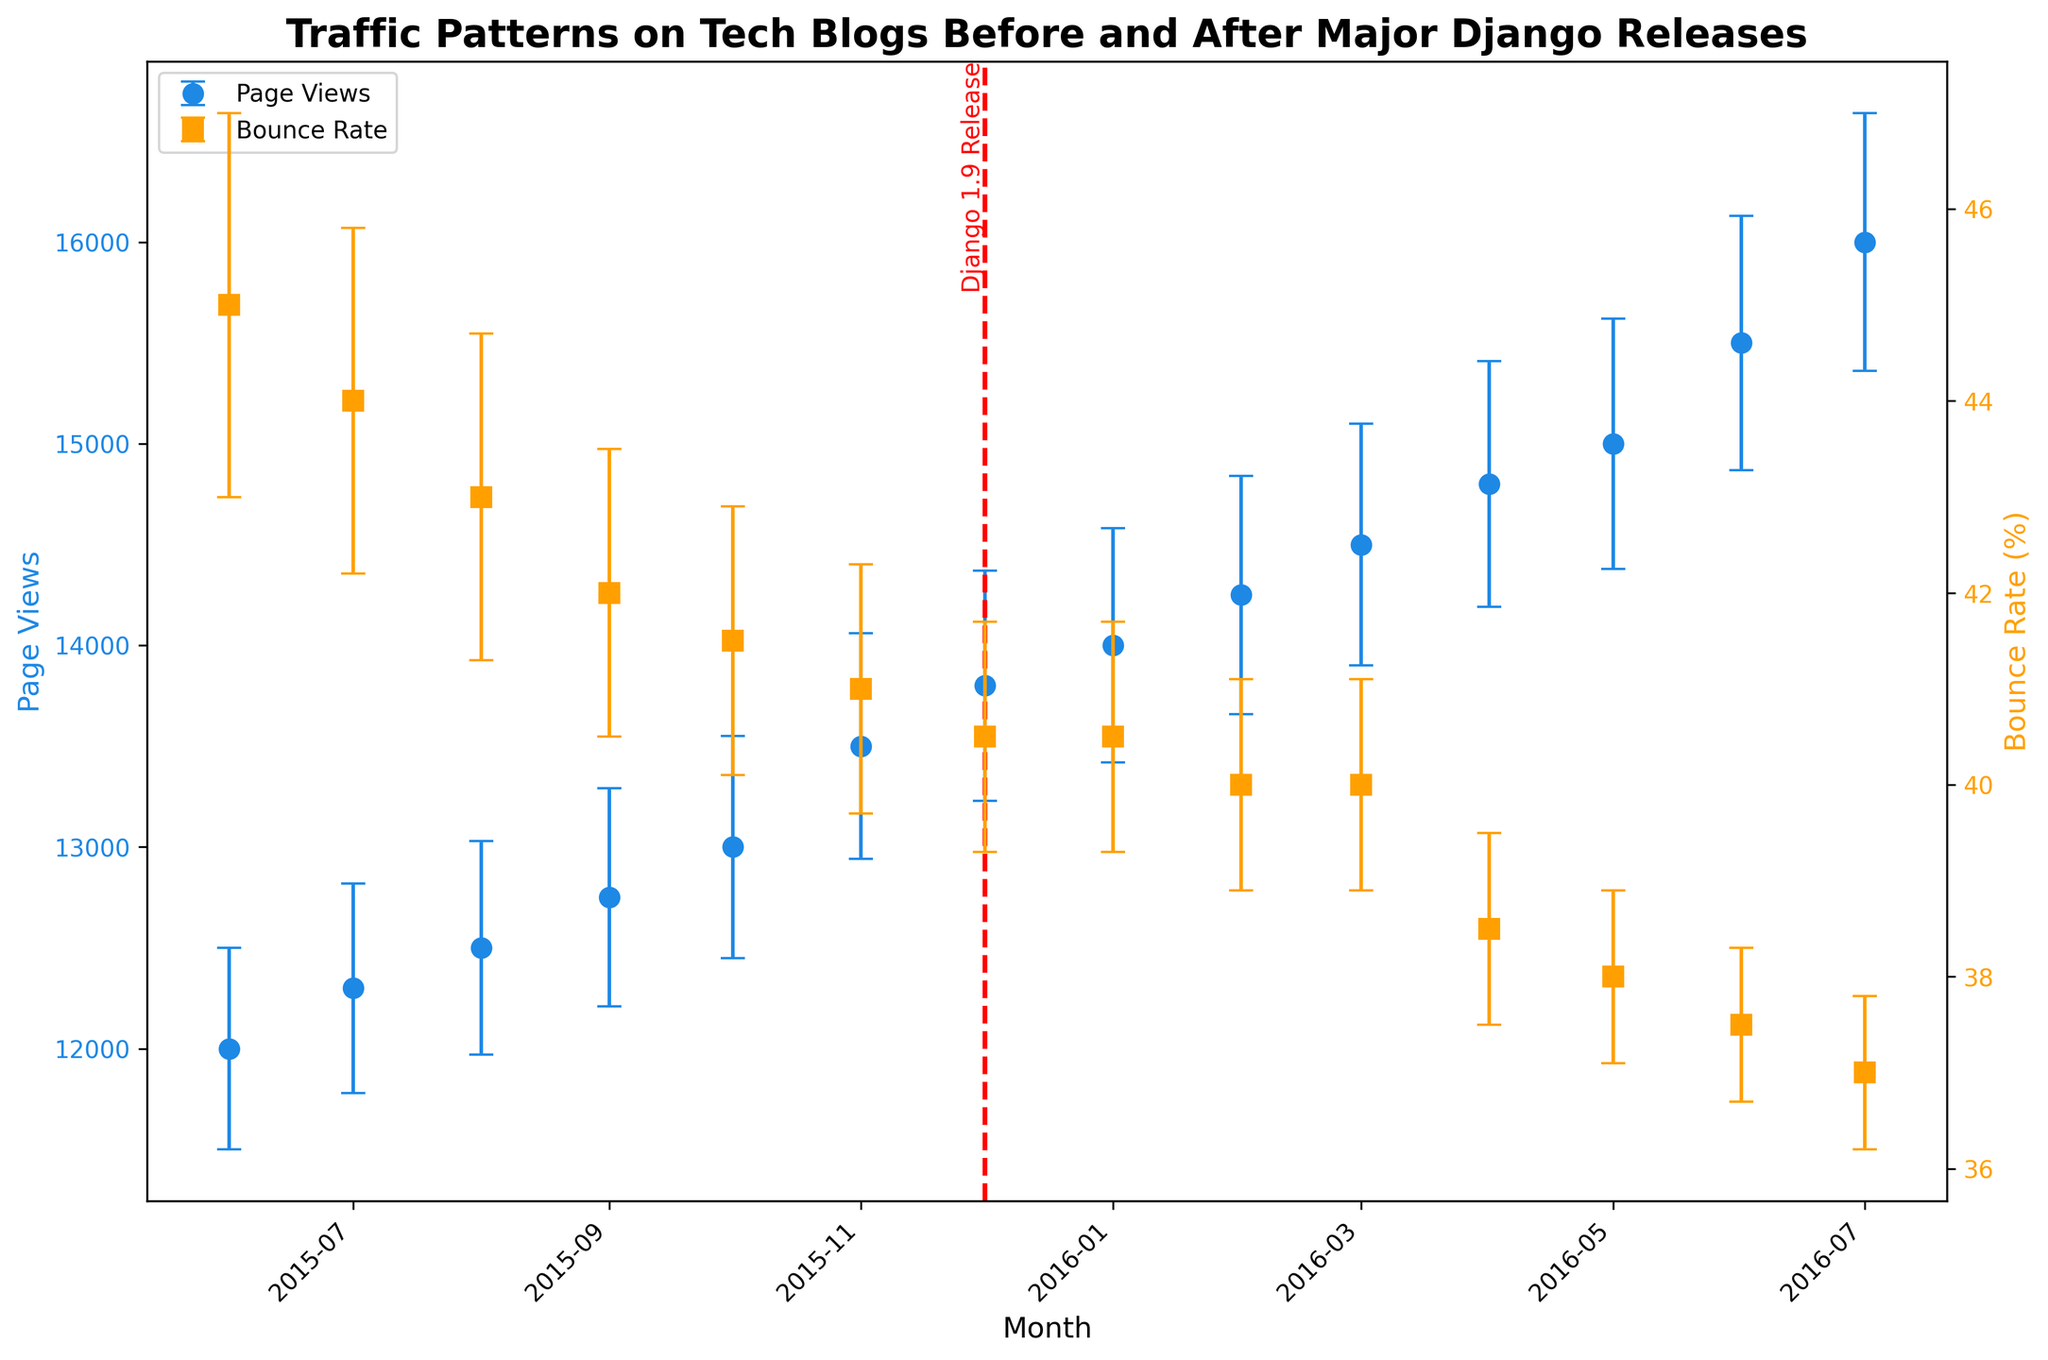What is the title of the plot? The title is displayed at the top of the plot. It reads: "Traffic Patterns on Tech Blogs Before and After Major Django Releases".
Answer: Traffic Patterns on Tech Blogs Before and After Major Django Releases What do the colors blue and orange represent in the plot? The colors are associated with the legends given on the plot. Blue (represented by circle markers) is for Page Views, and orange (represented by square markers) is for Bounce Rate.
Answer: Page Views (blue) and Bounce Rate (orange) How do the average page views change from June 2015 to July 2015? The y-axis value for page views increases from June to July. June shows an average of 12,000 page views, while July shows 12,300 page views, indicating an increase.
Answer: Increase from 12,000 to 12,300 What is the trend in the bounce rate from June 2015 to July 2016? The bounce rate generally decreases over time. In June 2015, it started at 45% and decreased to 37% by July 2016.
Answer: Decreasing trend How is the average bounce rate in March 2016 compared to that in April 2016? The plot shows that the average bounce rate in March 2016 is 40%, while in April 2016, it is 38.5%. This indicates a decrease in the bounce rate.
Answer: March 40%, April 38.5% What is the significance of the red vertical line on the plot? The red vertical line marks the release date of Django 1.9, which is December 1, 2015. It signifies that data before and after this date are separated for analysis.
Answer: Django 1.9 release date What is the error margin for page views in August 2015? The error margin for page views in August 2015 can be found using the Page_Views_STD value, which is ±530.
Answer: ±530 How does the variation in bounce rate (standard deviation) change from October 2015 to November 2015? The variation in bounce rate slightly decreases, with October having a standard deviation of 1.4 and November having 1.3.
Answer: Decreases What happens to the average page views right after the Django 1.9 release? The average page views continue to increase after the release, following the same trend. In December 2015, the average was 13,800 and increased to 14,000 in January 2016.
Answer: They continue to increase Which month has the highest average page views according to the plot? By comparing the points on the plot, it is evident that July 2016 has the highest average page views with 16,000.
Answer: July 2016 